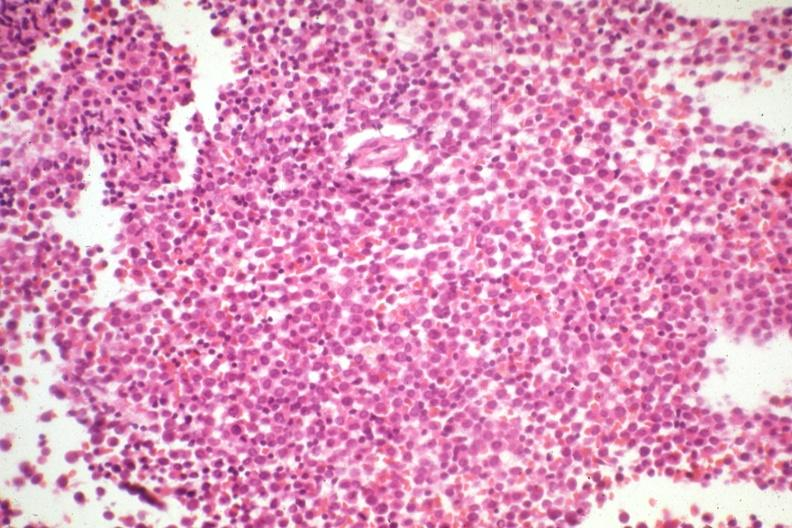what is this therapy had?
Answer the question using a single word or phrase. Not knocked out leukemia cells 